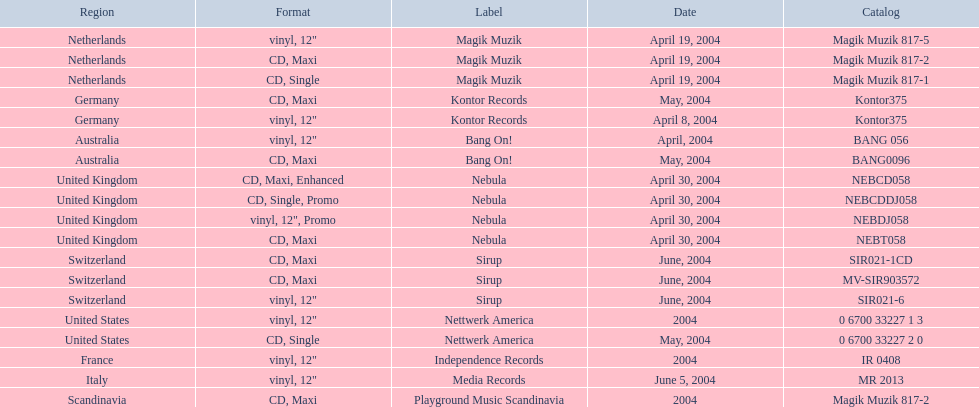How many catalogs were released? 19. 